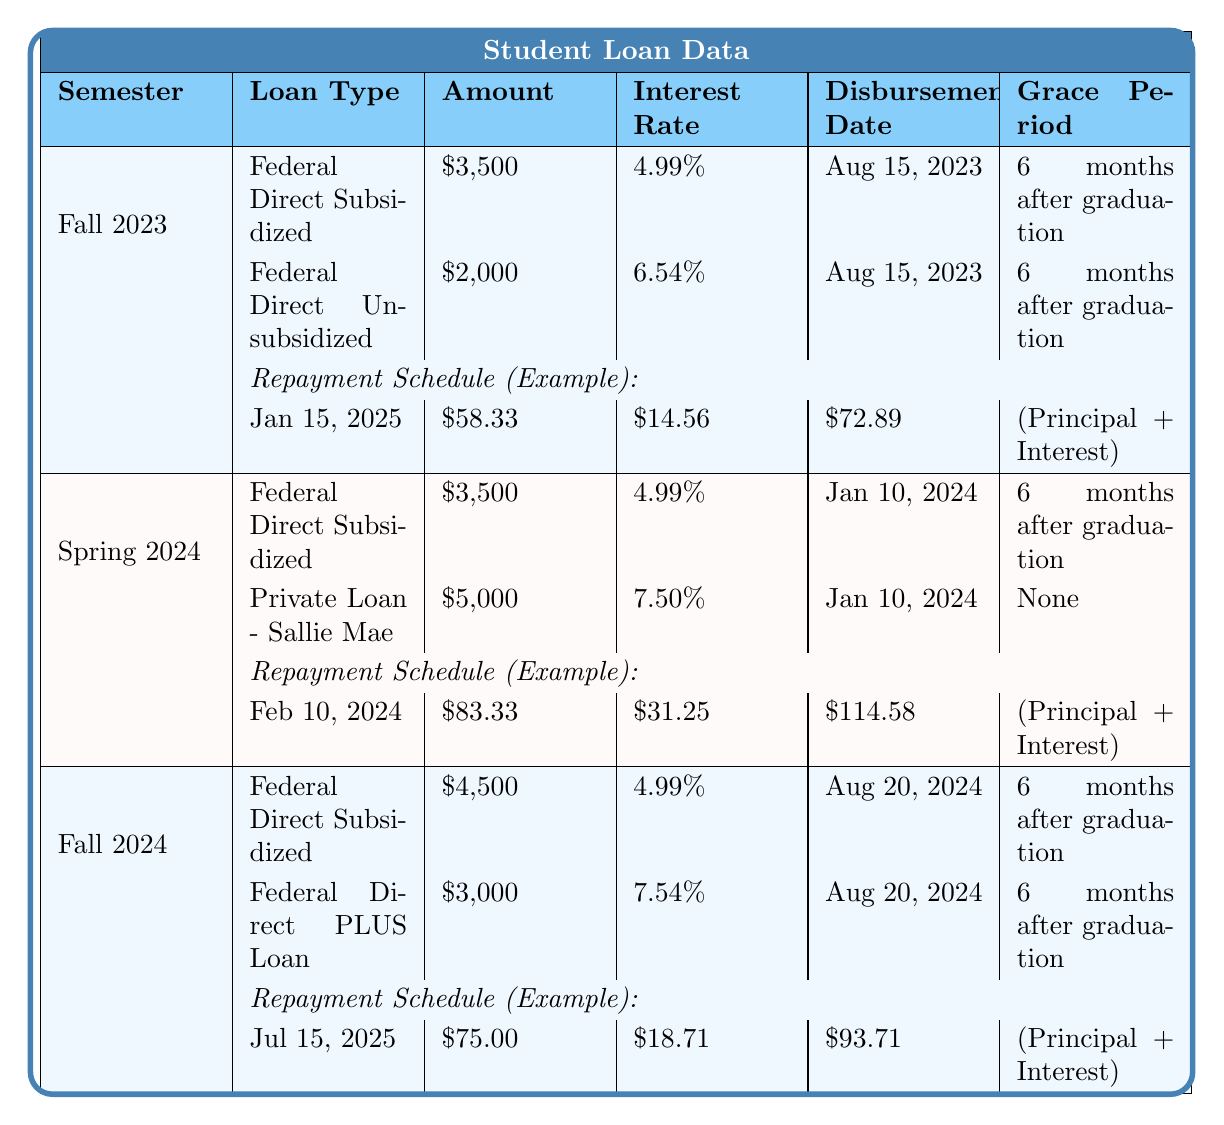What is the total amount of the Federal Direct Unsubsidized loan disbursed in Fall 2023? The total amount for the Federal Direct Unsubsidized loan in Fall 2023 is listed as $2,000.
Answer: $2,000 What are the interest rates for the loans disbursed in Spring 2024? The interest rates for the loans are 4.99% for the Federal Direct Subsidized loan and 7.50% for the Private Loan - Sallie Mae.
Answer: 4.99%, 7.50% Is there a grace period for the Private Loan - Sallie Mae? The grace period for the Private Loan - Sallie Mae is listed as "None."
Answer: No What is the total payment amount for the first repayment due on January 15, 2025, for the Federal Direct Subsidized loan from Fall 2023? The total payment for the first repayment on January 15, 2025, is $72.89.
Answer: $72.89 How much will be paid in principal and interest combined for the Federal Direct PLUS Loan in Fall 2024 at the second repayment date? For the second repayment on August 15, 2025, the total payment is $68.54, which is the sum of principal and interest.
Answer: $68.54 Which semester had the highest amount of Federal Direct Subsidized loans disbursed, and what was that amount? Fall 2024 had the highest amount of Federal Direct Subsidized loans at $4,500.
Answer: Fall 2024, $4,500 What is the average principal payment for the repayment schedules listed for all loan types in the Fall 2023 semester? In the Fall 2023 semester, there are two principal payments: $58.33 and $58.33. The average is calculated as (58.33 + 58.33) / 2 = 58.33.
Answer: $58.33 How many total payment dates are there for each loan type in Spring 2024? In Spring 2024, each loan type has two payment dates listed, making a total of 4 payment dates combined for both loans.
Answer: 4 What is the total interest paid for the first two repayment dates for the Federal Direct Subsidized loan issued in Fall 2024? The total interest for the first two repayments (July 15, 2025, and August 15, 2025) is $18.71 + $18.40 = $37.11.
Answer: $37.11 Is the disbursement date for the Federal Direct PLUS Loan the same as for the Federal Direct Subsidized loan in Fall 2024? Both loans were disbursed on August 20, 2024; therefore, the statement is true.
Answer: Yes What is the difference in total payment between the first and second repayment dates of the Federal Direct Subsidized loan from Fall 2023? The first repayment total payment is $72.89 and the second is $72.65. The difference is $72.89 - $72.65 = $0.24.
Answer: $0.24 